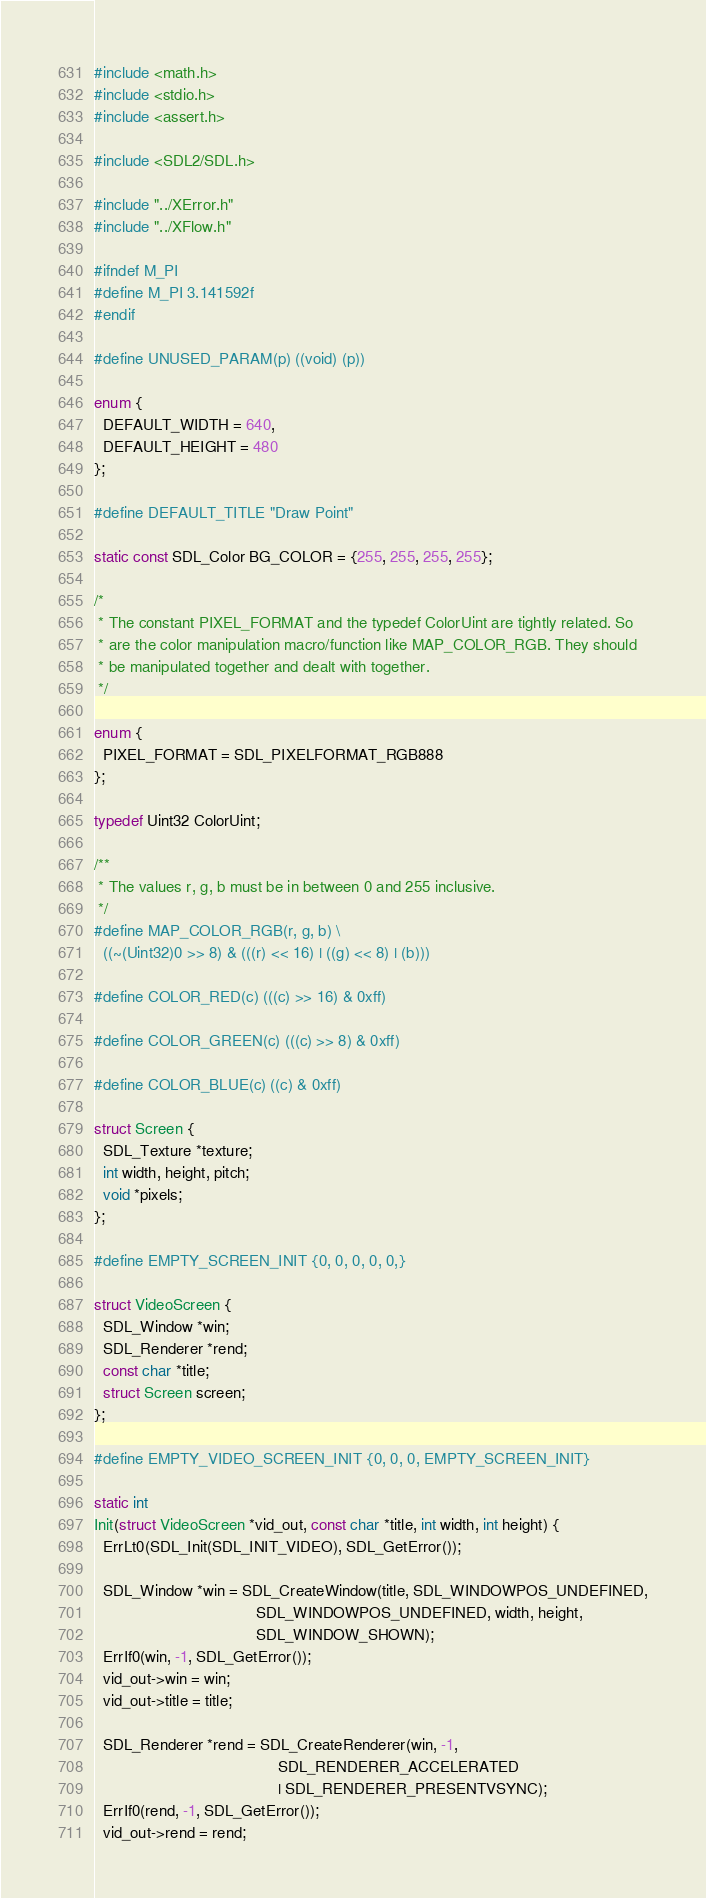<code> <loc_0><loc_0><loc_500><loc_500><_C_>#include <math.h>
#include <stdio.h>
#include <assert.h>

#include <SDL2/SDL.h>

#include "../XError.h"
#include "../XFlow.h"

#ifndef M_PI
#define M_PI 3.141592f
#endif

#define UNUSED_PARAM(p) ((void) (p))

enum {
  DEFAULT_WIDTH = 640,
  DEFAULT_HEIGHT = 480
};

#define DEFAULT_TITLE "Draw Point"

static const SDL_Color BG_COLOR = {255, 255, 255, 255};

/*
 * The constant PIXEL_FORMAT and the typedef ColorUint are tightly related. So
 * are the color manipulation macro/function like MAP_COLOR_RGB. They should
 * be manipulated together and dealt with together.
 */

enum {
  PIXEL_FORMAT = SDL_PIXELFORMAT_RGB888
};

typedef Uint32 ColorUint;

/**
 * The values r, g, b must be in between 0 and 255 inclusive.
 */
#define MAP_COLOR_RGB(r, g, b) \
  ((~(Uint32)0 >> 8) & (((r) << 16) | ((g) << 8) | (b)))

#define COLOR_RED(c) (((c) >> 16) & 0xff)

#define COLOR_GREEN(c) (((c) >> 8) & 0xff)

#define COLOR_BLUE(c) ((c) & 0xff)

struct Screen {
  SDL_Texture *texture;
  int width, height, pitch;
  void *pixels;
};

#define EMPTY_SCREEN_INIT {0, 0, 0, 0, 0,}

struct VideoScreen {
  SDL_Window *win;
  SDL_Renderer *rend;
  const char *title;
  struct Screen screen;
};

#define EMPTY_VIDEO_SCREEN_INIT {0, 0, 0, EMPTY_SCREEN_INIT}

static int
Init(struct VideoScreen *vid_out, const char *title, int width, int height) {
  ErrLt0(SDL_Init(SDL_INIT_VIDEO), SDL_GetError());

  SDL_Window *win = SDL_CreateWindow(title, SDL_WINDOWPOS_UNDEFINED,
                                     SDL_WINDOWPOS_UNDEFINED, width, height,
                                     SDL_WINDOW_SHOWN);
  ErrIf0(win, -1, SDL_GetError());
  vid_out->win = win;
  vid_out->title = title;

  SDL_Renderer *rend = SDL_CreateRenderer(win, -1,
                                          SDL_RENDERER_ACCELERATED
                                          | SDL_RENDERER_PRESENTVSYNC);
  ErrIf0(rend, -1, SDL_GetError());
  vid_out->rend = rend;
</code> 